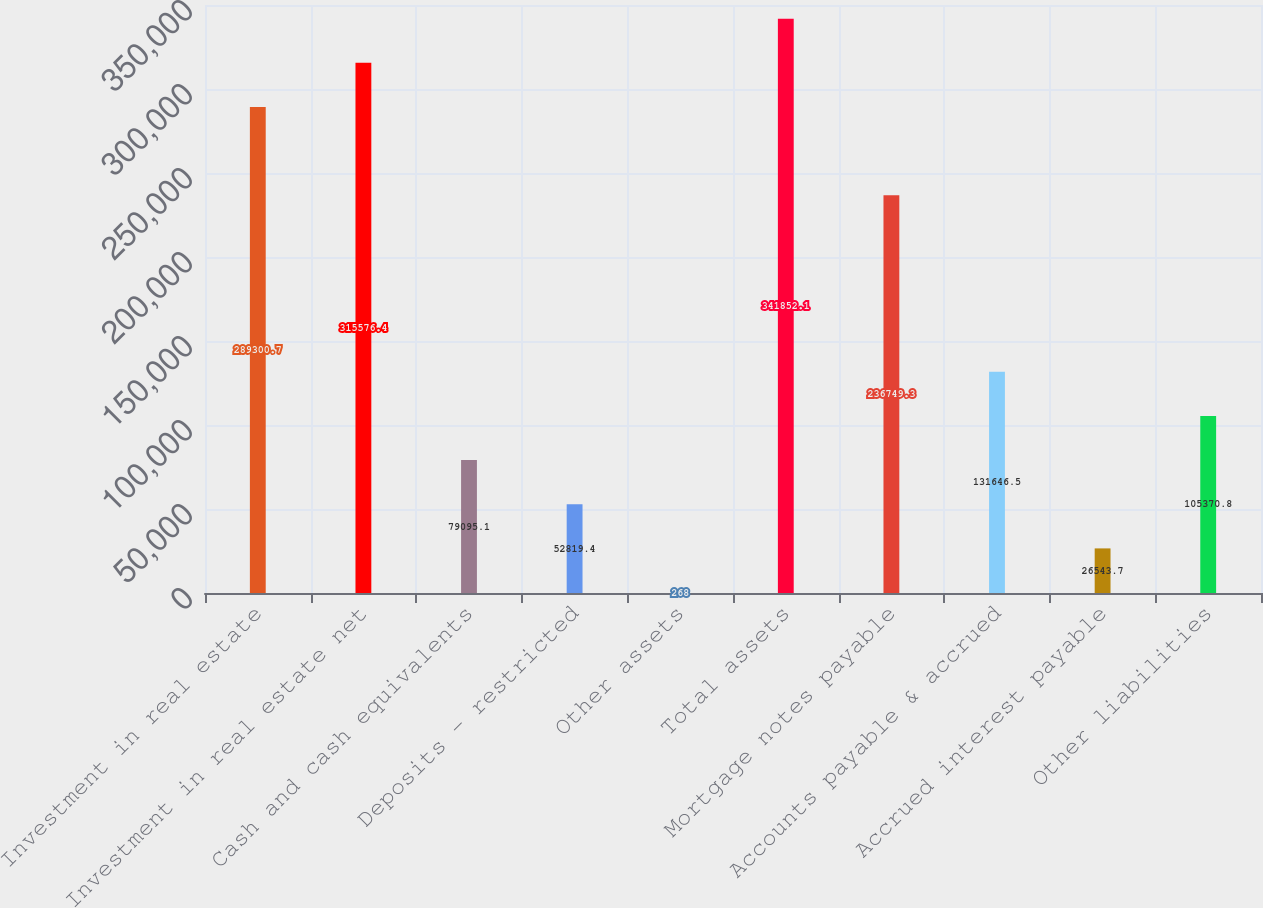Convert chart. <chart><loc_0><loc_0><loc_500><loc_500><bar_chart><fcel>Investment in real estate<fcel>Investment in real estate net<fcel>Cash and cash equivalents<fcel>Deposits - restricted<fcel>Other assets<fcel>Total assets<fcel>Mortgage notes payable<fcel>Accounts payable & accrued<fcel>Accrued interest payable<fcel>Other liabilities<nl><fcel>289301<fcel>315576<fcel>79095.1<fcel>52819.4<fcel>268<fcel>341852<fcel>236749<fcel>131646<fcel>26543.7<fcel>105371<nl></chart> 